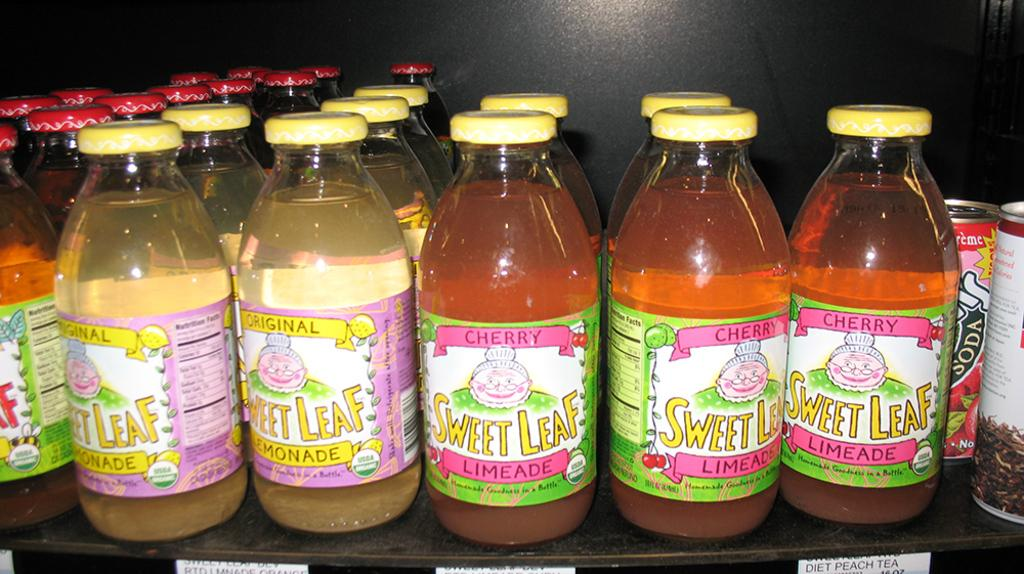<image>
Write a terse but informative summary of the picture. a variation of sweet leaf bottles including the flavor limeade 